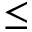<formula> <loc_0><loc_0><loc_500><loc_500>\leq</formula> 